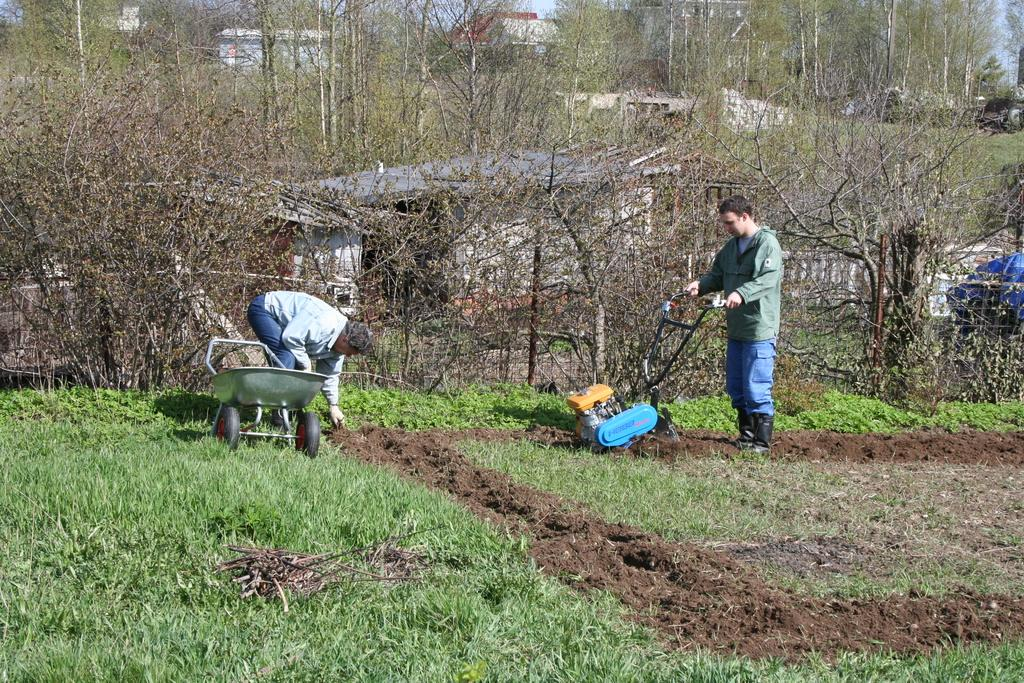How many people are in the image? There are two men in the image. What are the men wearing? The men are wearing clothes. What type of natural environment is visible in the image? There is soil, grass, and trees visible in the image. What type of man-made structures can be seen in the image? There are buildings in the image. What is the color of the sky in the image? The sky is pale blue in the image. What type of equipment is present in the image? There is a machine in the image. How many sisters are present in the image? There are no sisters mentioned or visible in the image. What is the position of the sun in the image? The provided facts do not mention the position of the sun in the image. 